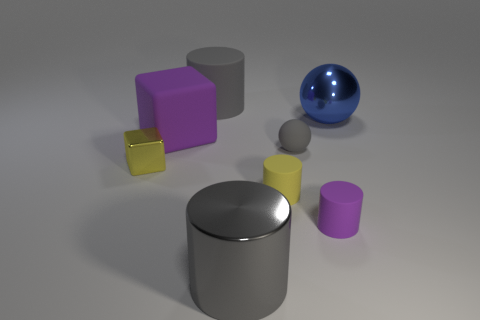There is a big thing that is the same color as the large rubber cylinder; what is it made of?
Make the answer very short. Metal. What is the color of the cylinder behind the big blue metallic object that is behind the big purple rubber cube?
Provide a short and direct response. Gray. Are there any big rubber objects of the same color as the small ball?
Keep it short and to the point. Yes. There is a gray thing that is the same size as the yellow metal thing; what is its shape?
Provide a succinct answer. Sphere. How many purple rubber cylinders are right of the cylinder that is on the right side of the yellow matte cylinder?
Provide a succinct answer. 0. Do the tiny metallic object and the metallic cylinder have the same color?
Give a very brief answer. No. How many other objects are there of the same material as the blue thing?
Your answer should be compact. 2. There is a large shiny thing left of the big metal thing that is behind the yellow cylinder; what is its shape?
Keep it short and to the point. Cylinder. What is the size of the rubber cylinder that is behind the yellow shiny thing?
Provide a short and direct response. Large. Do the tiny gray sphere and the yellow cube have the same material?
Ensure brevity in your answer.  No. 